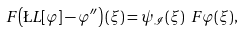<formula> <loc_0><loc_0><loc_500><loc_500>\ F \left ( \L L [ \varphi ] - \varphi ^ { \prime \prime } \right ) ( \xi ) = \psi _ { \mathcal { I } } ( \xi ) \ F \varphi ( \xi ) ,</formula> 